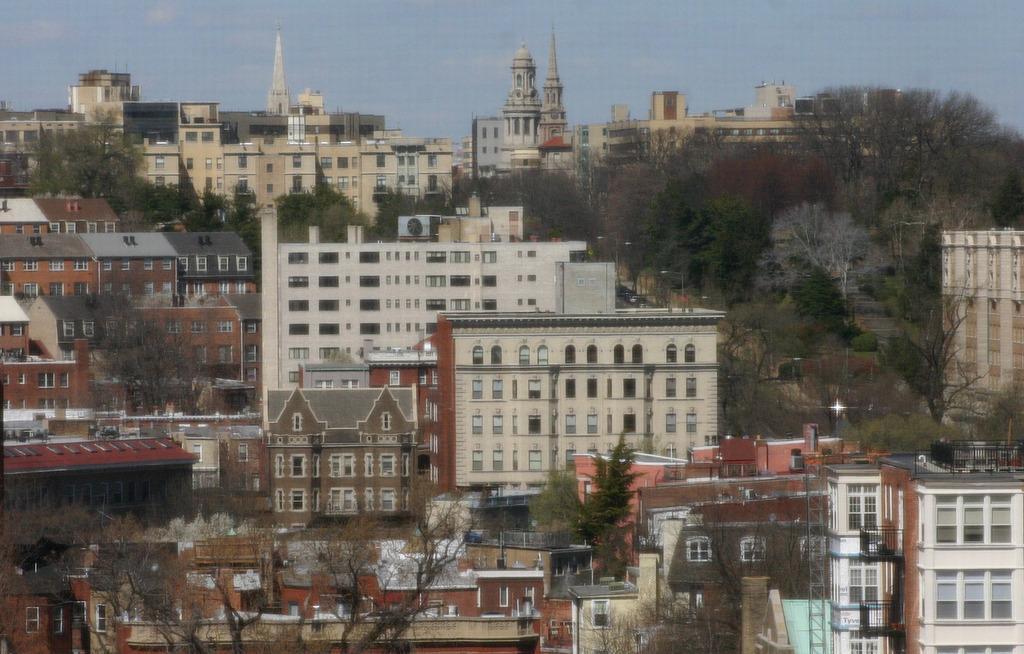How would you summarize this image in a sentence or two? In the picture I can see buildings, trees, poles and some other objects. In the background I can see the sky. 